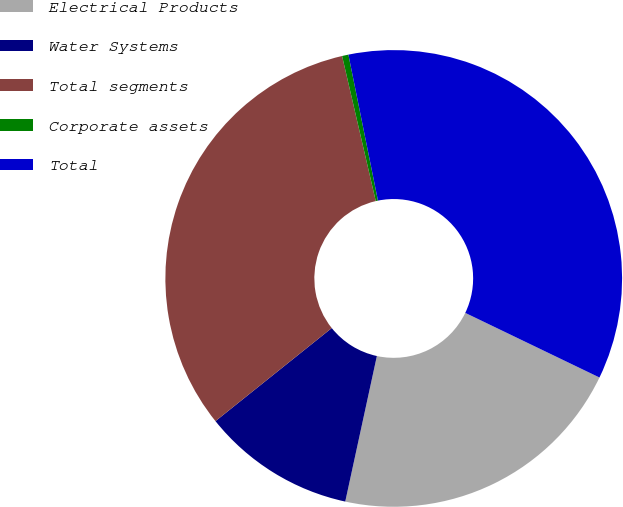<chart> <loc_0><loc_0><loc_500><loc_500><pie_chart><fcel>Electrical Products<fcel>Water Systems<fcel>Total segments<fcel>Corporate assets<fcel>Total<nl><fcel>21.26%<fcel>10.85%<fcel>32.11%<fcel>0.45%<fcel>35.32%<nl></chart> 